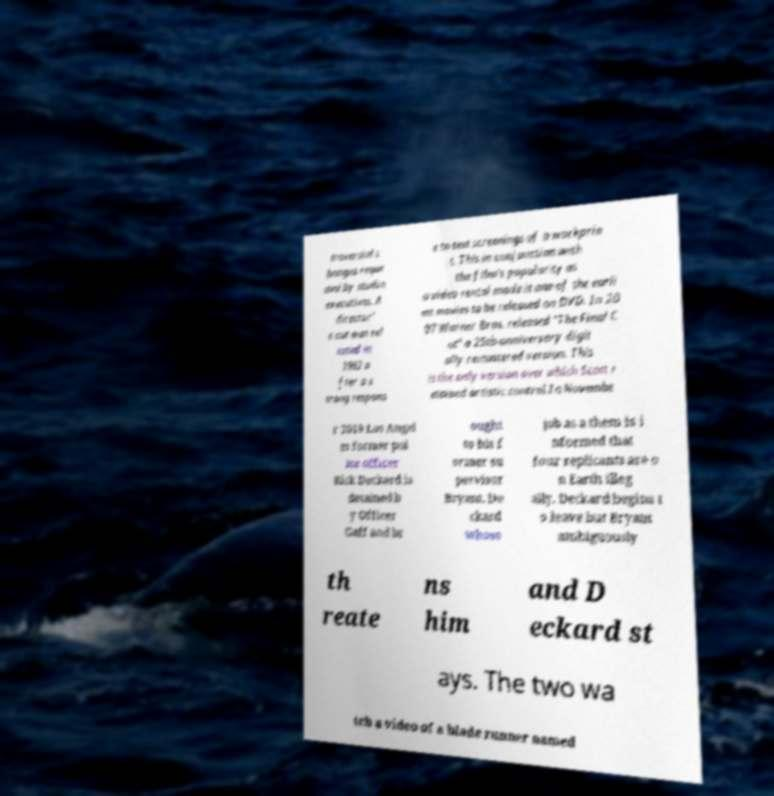Please identify and transcribe the text found in this image. troversial c hanges reque sted by studio executives. A director' s cut was rel eased in 1992 a fter a s trong respons e to test screenings of a workprin t. This in conjunction with the film's popularity as a video rental made it one of the earli est movies to be released on DVD. In 20 07 Warner Bros. released "The Final C ut" a 25th-anniversary digit ally remastered version. This is the only version over which Scott r etained artistic control.In Novembe r 2019 Los Angel es former pol ice officer Rick Deckard is detained b y Officer Gaff and br ought to his f ormer su pervisor Bryant. De ckard whose job as a them is i nformed that four replicants are o n Earth illeg ally. Deckard begins t o leave but Bryant ambiguously th reate ns him and D eckard st ays. The two wa tch a video of a blade runner named 